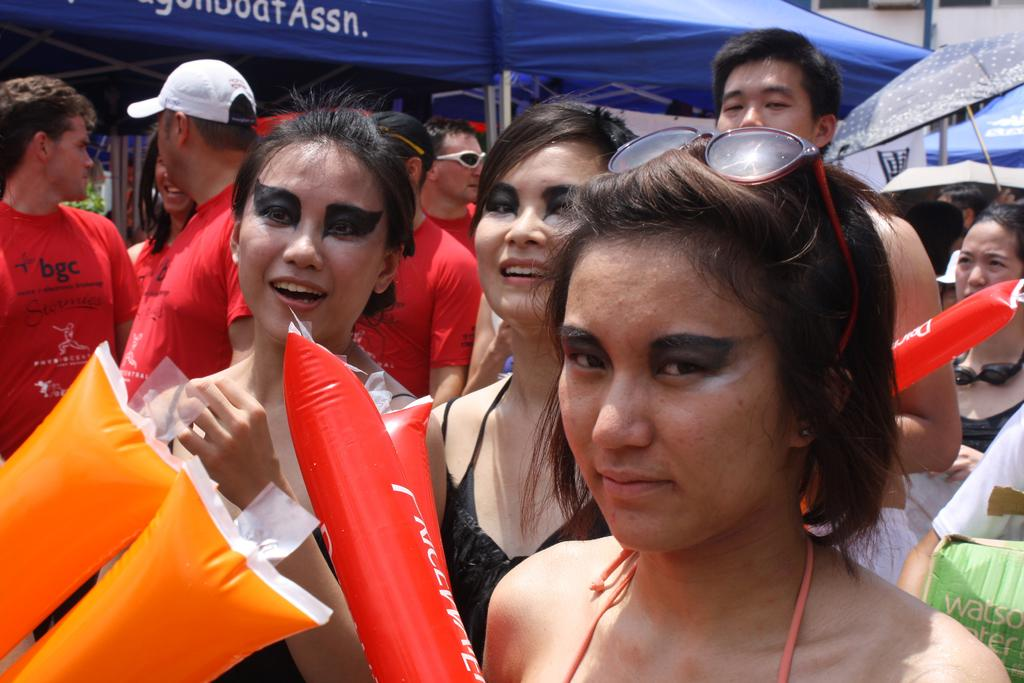What are the people in the image doing? The people in the image are standing in the middle of the image. What are the people holding in the image? The people are holding balloons. What can be seen in the background of the image? There are tents visible in the background of the image. Can you tell me how many people are laughing in the image? There is no indication of anyone laughing in the image. 